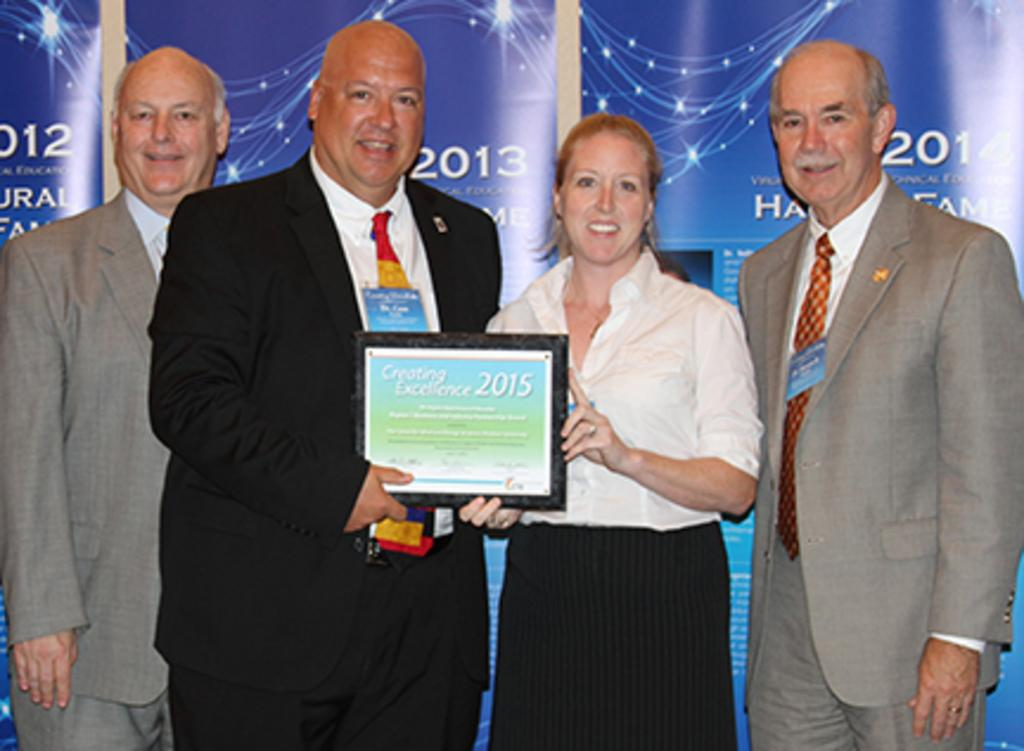How many people are present in the image? There are four persons standing in the image. What is the facial expression of the persons in the image? The persons are smiling. What are the persons holding in the image? The persons are holding a frame. What can be seen in the background behind the persons? There is a banner visible behind the persons. What type of camera can be seen in the image? There is no camera present in the image. What is the toad doing in the image? There is no toad present in the image. 